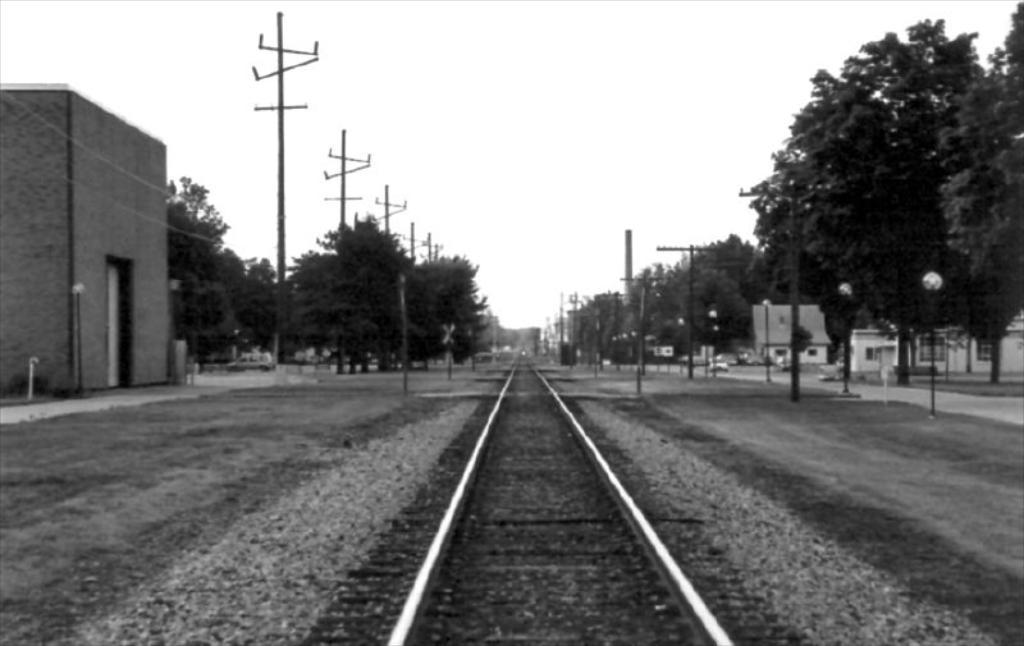What type of transportation infrastructure is present in the image? There is a railway track in the image. What else can be seen in the image besides the railway track? Buildings, poles, trees, and a car moving on the road are visible in the image. Can you describe the type of structures present in the image? The buildings in the image are likely residential or commercial structures. What is the car doing in the image? A car is moving on the road in the image. What type of sugar is being used to sweeten the behavior of the trees in the image? There is no sugar or behavior mentioned in the image; it features a railway track, buildings, poles, trees, and a moving car. 